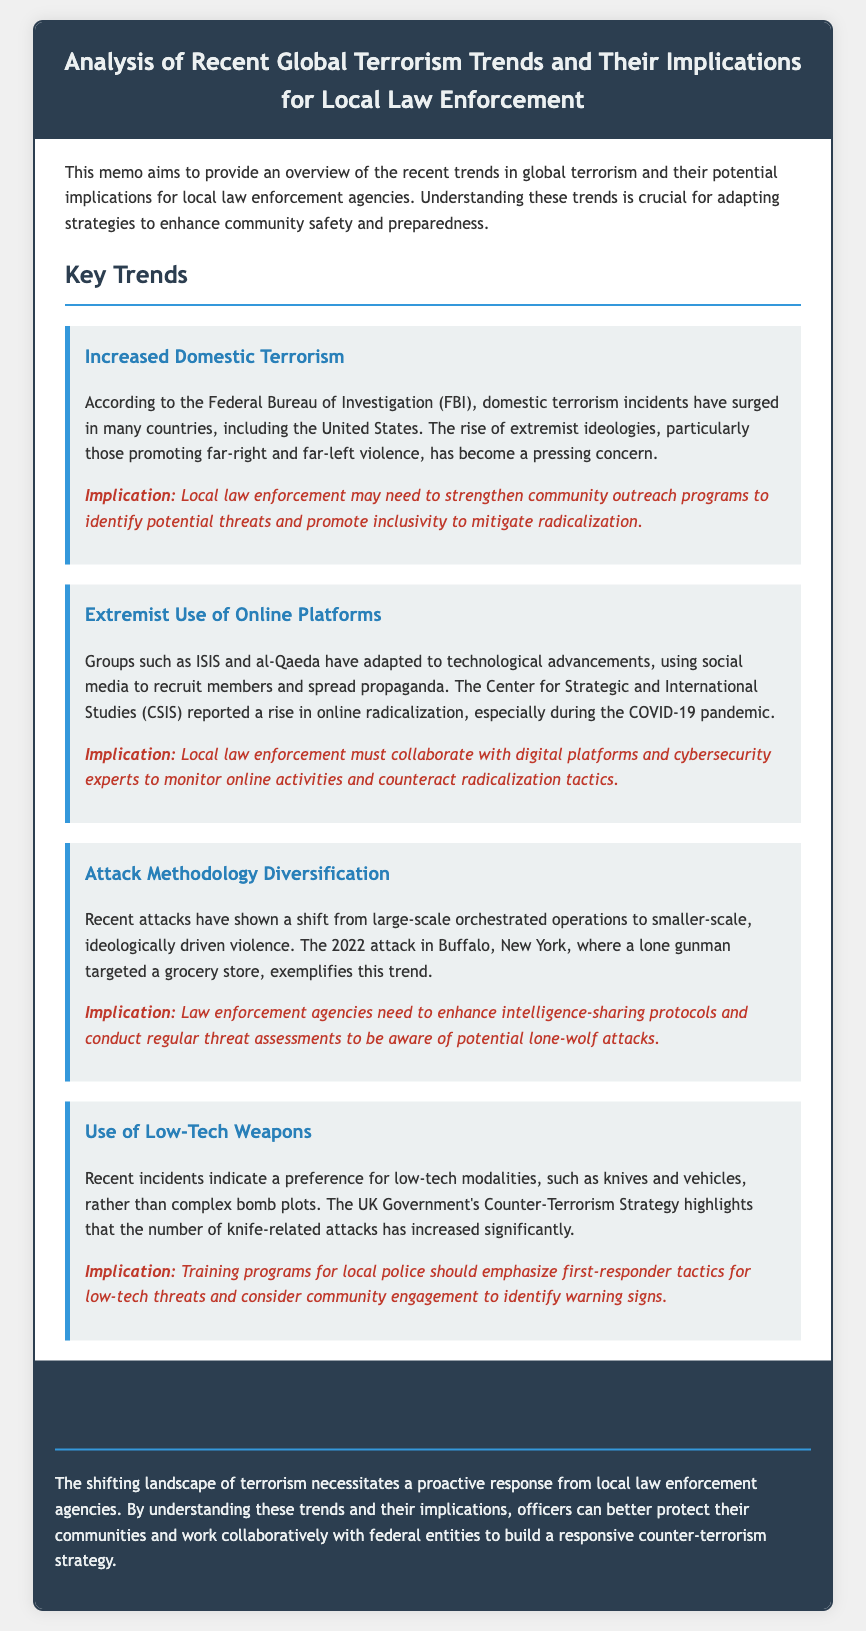What is the title of the memo? The title is clearly stated at the beginning of the document.
Answer: Analysis of Recent Global Terrorism Trends and Their Implications for Local Law Enforcement Which organization reported an increase in domestic terrorism incidents? The organization responsible for reporting this information is mentioned in relation to domestic terrorism trends.
Answer: Federal Bureau of Investigation What shift in attack methodology is noted in the memo? The document discusses a specific trend regarding the nature of attacks that is highlighted in one of the sections.
Answer: Diversification What type of online platforms are mentioned concerning extremist groups? The memo addresses the adaptation of extremist groups to technological advancements, including specific platforms.
Answer: Social media What is one implication of the increased use of low-tech weapons? The memo includes implications that suggest training for local police based on recent findings about weapons used.
Answer: First-responder tactics What significant event is cited as an example of a lone-wolf attack? The document provides an example of a recent incident to illustrate a trend in attack methodology.
Answer: 2022 attack in Buffalo, New York Which pandemic is mentioned as contributing to a rise in online radicalization? The memo references a specific global event that has affected radicalization trends.
Answer: COVID-19 What is emphasized as necessary for law enforcement regarding community outreach? The need for action in a specific area is highlighted in the implications of one of the key trends.
Answer: Strengthen community outreach programs 